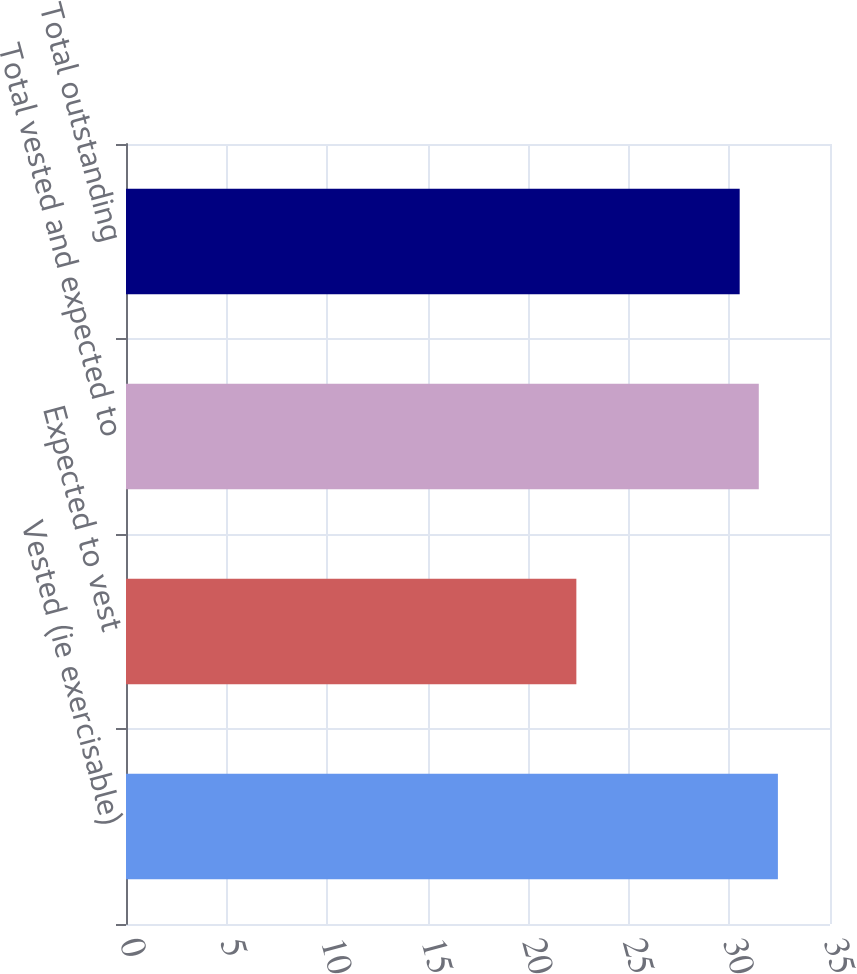Convert chart to OTSL. <chart><loc_0><loc_0><loc_500><loc_500><bar_chart><fcel>Vested (ie exercisable)<fcel>Expected to vest<fcel>Total vested and expected to<fcel>Total outstanding<nl><fcel>32.41<fcel>22.39<fcel>31.46<fcel>30.51<nl></chart> 